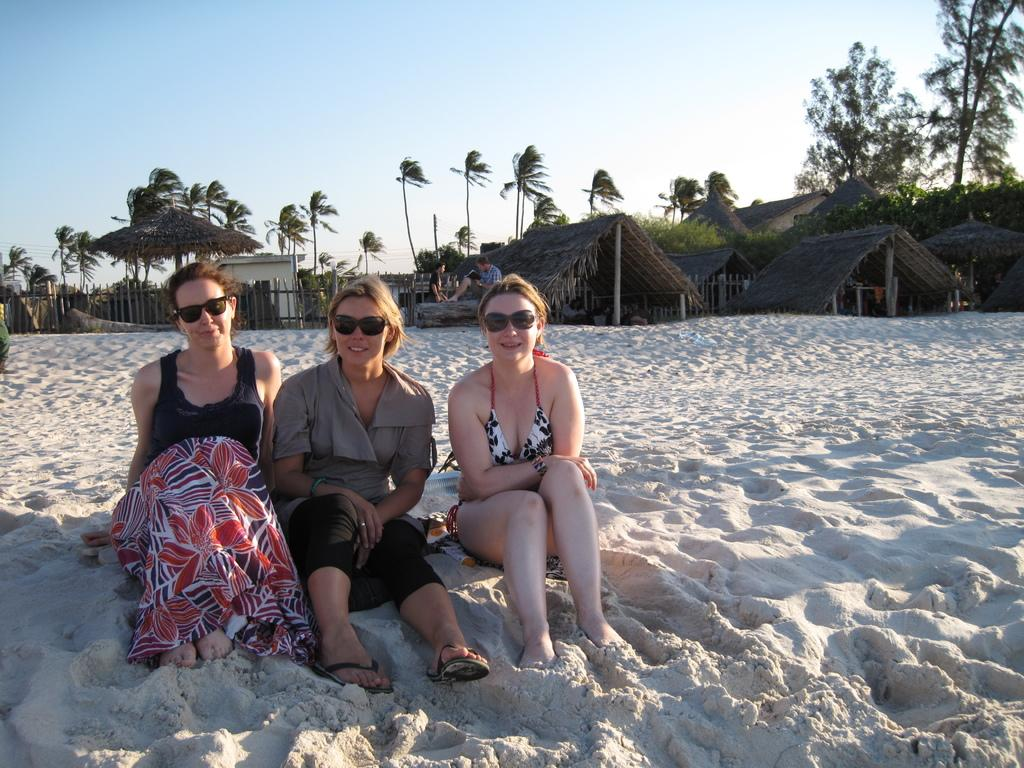What are the women in the image doing? The women in the image are sitting on the sand. What are the women wearing in the image? The women are wearing black color shades. What can be seen in the background of the image? There are people, trees, beach huts, and the sky visible in the background of the image. Can you see any trucks carrying apples in the image? There are no trucks or apples present in the image. Is there a snail crawling on the sand near the women? There is no snail visible in the image. 